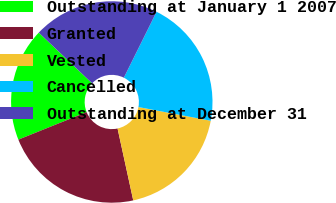Convert chart to OTSL. <chart><loc_0><loc_0><loc_500><loc_500><pie_chart><fcel>Outstanding at January 1 2007<fcel>Granted<fcel>Vested<fcel>Cancelled<fcel>Outstanding at December 31<nl><fcel>18.19%<fcel>22.32%<fcel>18.6%<fcel>20.65%<fcel>20.24%<nl></chart> 